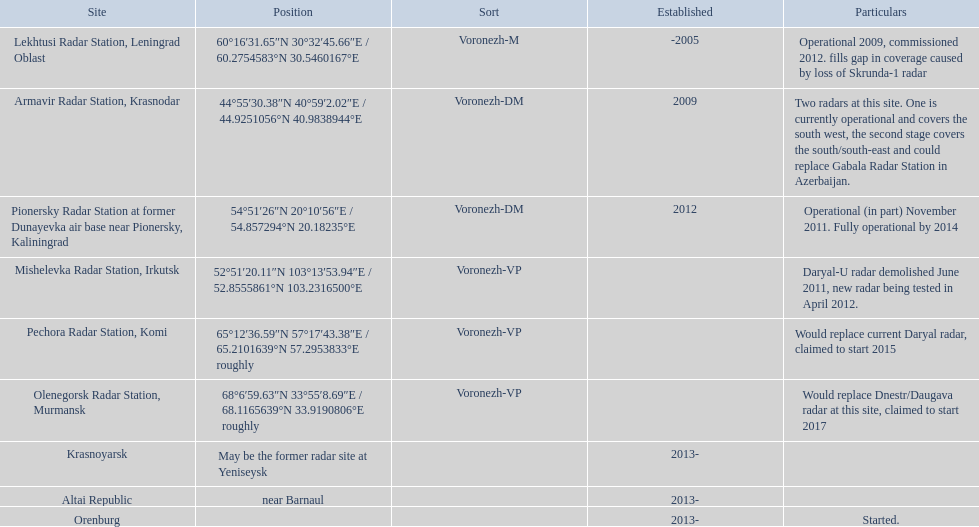What was the duration for the pionersky radar station to transition from partially operational to completely operational? 3 years. Would you be able to parse every entry in this table? {'header': ['Site', 'Position', 'Sort', 'Established', 'Particulars'], 'rows': [['Lekhtusi Radar Station, Leningrad Oblast', '60°16′31.65″N 30°32′45.66″E\ufeff / \ufeff60.2754583°N 30.5460167°E', 'Voronezh-M', '-2005', 'Operational 2009, commissioned 2012. fills gap in coverage caused by loss of Skrunda-1 radar'], ['Armavir Radar Station, Krasnodar', '44°55′30.38″N 40°59′2.02″E\ufeff / \ufeff44.9251056°N 40.9838944°E', 'Voronezh-DM', '2009', 'Two radars at this site. One is currently operational and covers the south west, the second stage covers the south/south-east and could replace Gabala Radar Station in Azerbaijan.'], ['Pionersky Radar Station at former Dunayevka air base near Pionersky, Kaliningrad', '54°51′26″N 20°10′56″E\ufeff / \ufeff54.857294°N 20.18235°E', 'Voronezh-DM', '2012', 'Operational (in part) November 2011. Fully operational by 2014'], ['Mishelevka Radar Station, Irkutsk', '52°51′20.11″N 103°13′53.94″E\ufeff / \ufeff52.8555861°N 103.2316500°E', 'Voronezh-VP', '', 'Daryal-U radar demolished June 2011, new radar being tested in April 2012.'], ['Pechora Radar Station, Komi', '65°12′36.59″N 57°17′43.38″E\ufeff / \ufeff65.2101639°N 57.2953833°E roughly', 'Voronezh-VP', '', 'Would replace current Daryal radar, claimed to start 2015'], ['Olenegorsk Radar Station, Murmansk', '68°6′59.63″N 33°55′8.69″E\ufeff / \ufeff68.1165639°N 33.9190806°E roughly', 'Voronezh-VP', '', 'Would replace Dnestr/Daugava radar at this site, claimed to start 2017'], ['Krasnoyarsk', 'May be the former radar site at Yeniseysk', '', '2013-', ''], ['Altai Republic', 'near Barnaul', '', '2013-', ''], ['Orenburg', '', '', '2013-', 'Started.']]} 